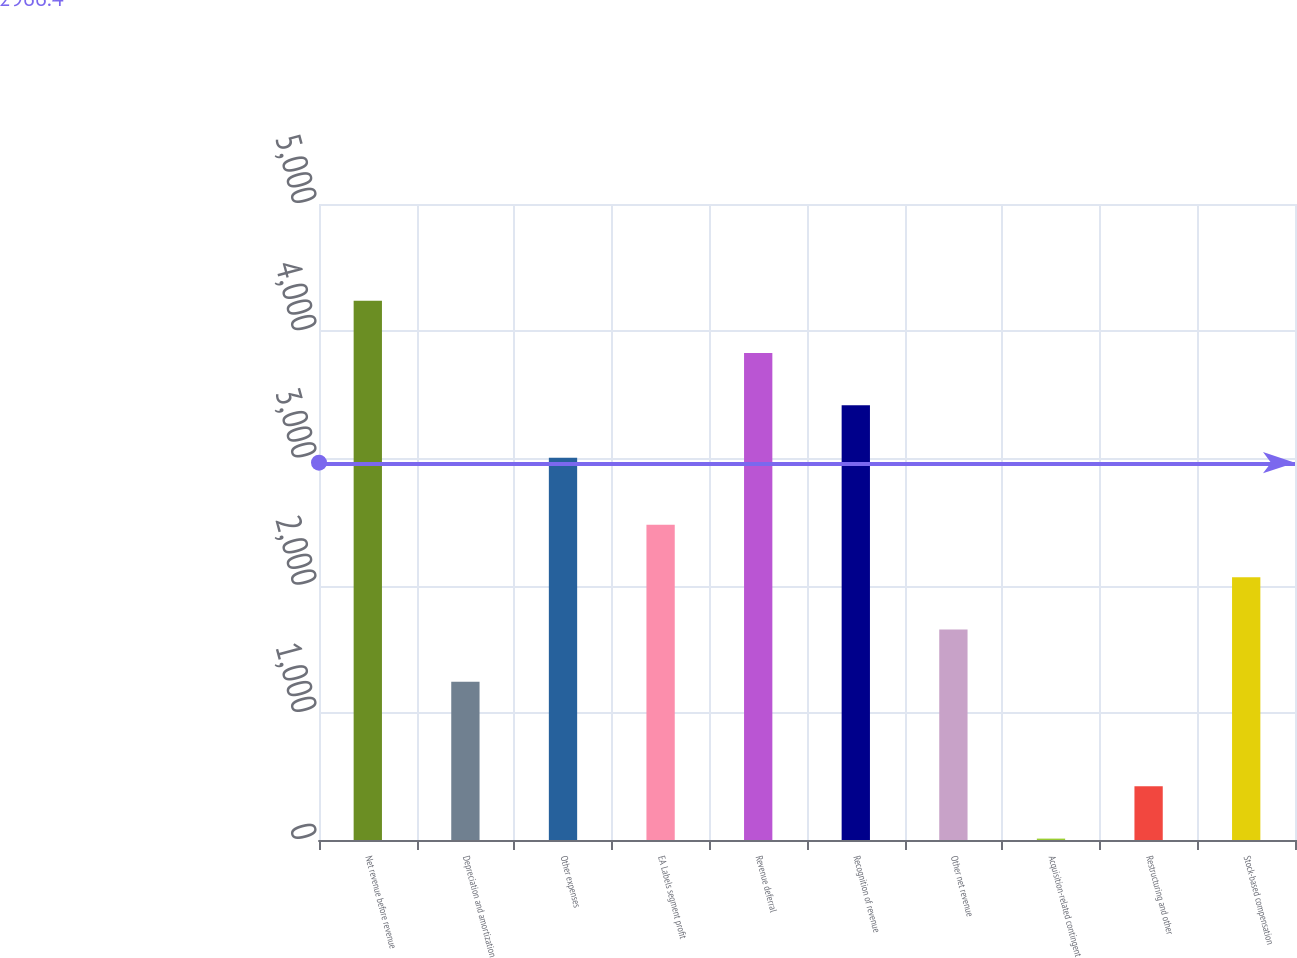Convert chart to OTSL. <chart><loc_0><loc_0><loc_500><loc_500><bar_chart><fcel>Net revenue before revenue<fcel>Depreciation and amortization<fcel>Other expenses<fcel>EA Labels segment profit<fcel>Revenue deferral<fcel>Recognition of revenue<fcel>Other net revenue<fcel>Acquisition-related contingent<fcel>Restructuring and other<fcel>Stock-based compensation<nl><fcel>4239.3<fcel>1244.3<fcel>3006<fcel>2477.6<fcel>3828.2<fcel>3417.1<fcel>1655.4<fcel>11<fcel>422.1<fcel>2066.5<nl></chart> 